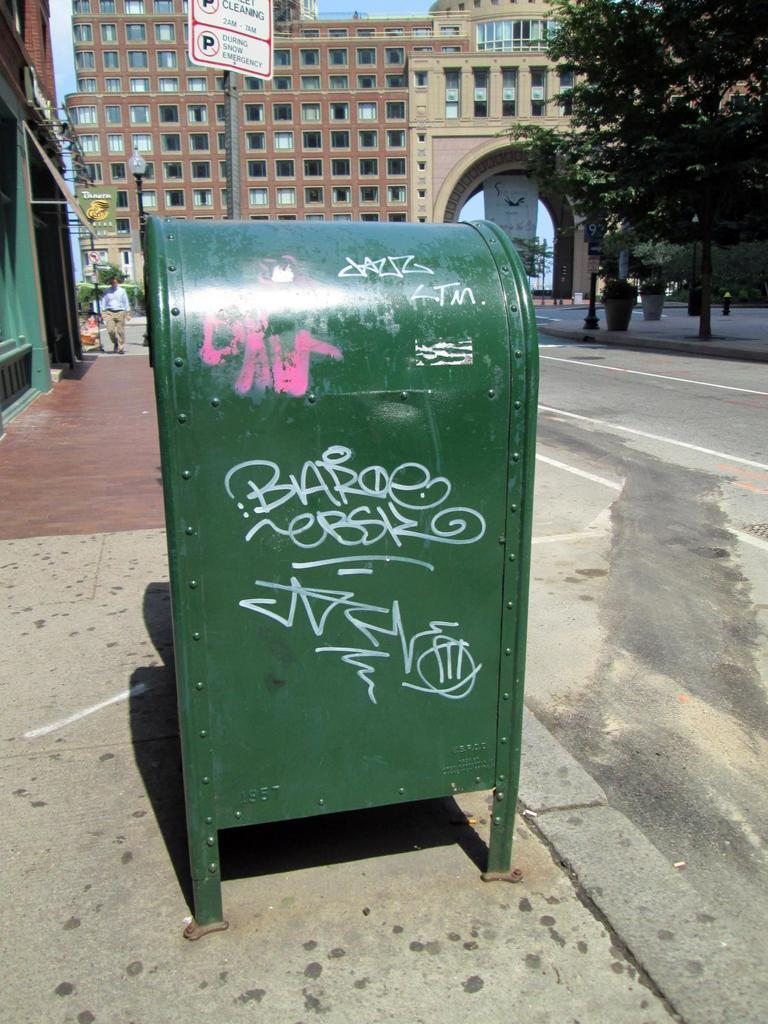<image>
Relay a brief, clear account of the picture shown. Green mailbox under a sign which says no parking during snow emergency. 